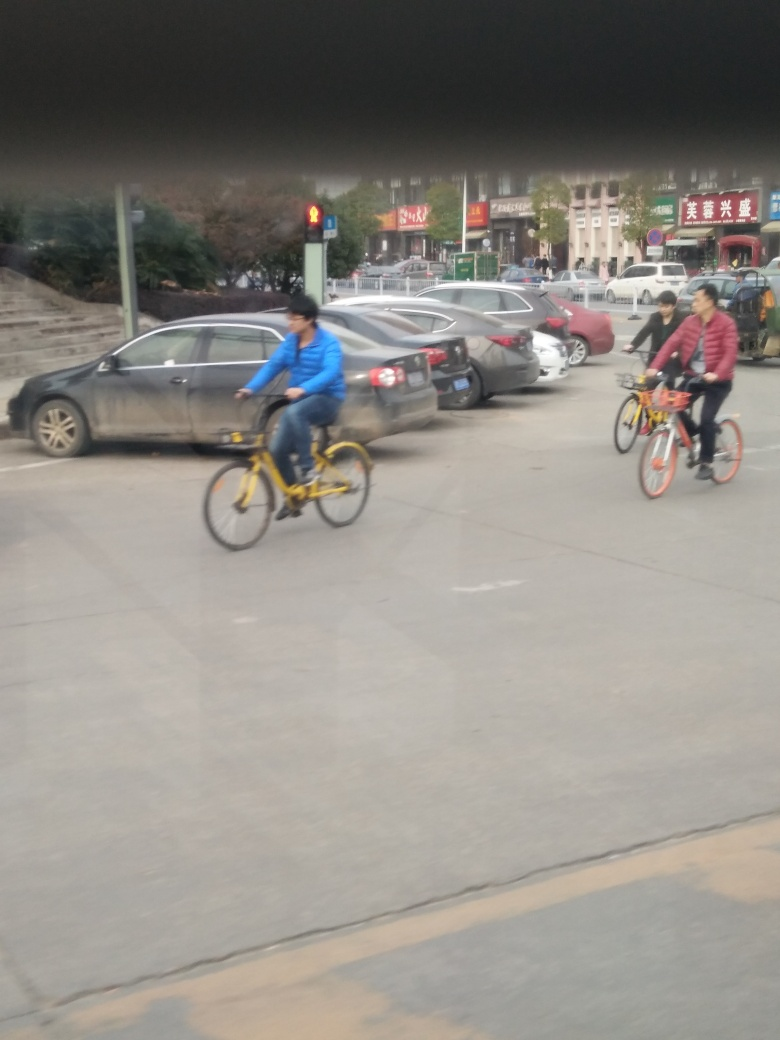What is the weather like in this image? The sky looks overcast with no direct sunlight visible, which suggests it might be a cloudy day. The absence of people in heavy jackets or umbrellas suggests it is not rainy or extremely cold. 